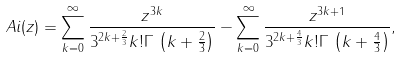<formula> <loc_0><loc_0><loc_500><loc_500>\ A i ( z ) = \sum _ { k = 0 } ^ { \infty } \frac { z ^ { 3 k } } { 3 ^ { 2 k + \frac { 2 } { 3 } } k ! \Gamma \, \left ( k + \frac { 2 } { 3 } \right ) } - \sum _ { k = 0 } ^ { \infty } \frac { z ^ { 3 k + 1 } } { 3 ^ { 2 k + \frac { 4 } { 3 } } k ! \Gamma \, \left ( k + \frac { 4 } { 3 } \right ) } ,</formula> 